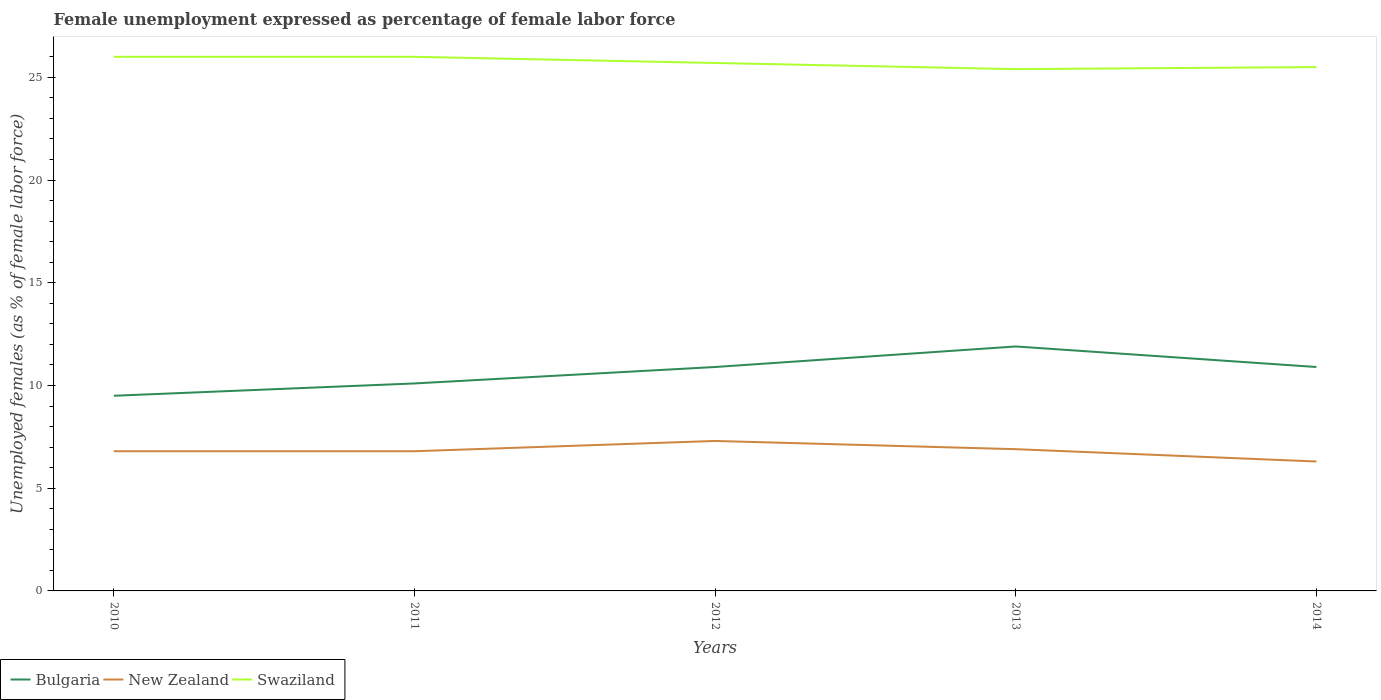How many different coloured lines are there?
Ensure brevity in your answer.  3. Across all years, what is the maximum unemployment in females in in Bulgaria?
Your answer should be compact. 9.5. What is the total unemployment in females in in Swaziland in the graph?
Provide a short and direct response. -0.1. What is the difference between the highest and the second highest unemployment in females in in New Zealand?
Ensure brevity in your answer.  1. What is the difference between the highest and the lowest unemployment in females in in New Zealand?
Your answer should be very brief. 2. How many lines are there?
Give a very brief answer. 3. What is the difference between two consecutive major ticks on the Y-axis?
Your response must be concise. 5. Are the values on the major ticks of Y-axis written in scientific E-notation?
Your answer should be compact. No. Does the graph contain any zero values?
Make the answer very short. No. Does the graph contain grids?
Ensure brevity in your answer.  No. How many legend labels are there?
Provide a succinct answer. 3. How are the legend labels stacked?
Your answer should be very brief. Horizontal. What is the title of the graph?
Ensure brevity in your answer.  Female unemployment expressed as percentage of female labor force. Does "Upper middle income" appear as one of the legend labels in the graph?
Offer a terse response. No. What is the label or title of the Y-axis?
Keep it short and to the point. Unemployed females (as % of female labor force). What is the Unemployed females (as % of female labor force) of New Zealand in 2010?
Provide a short and direct response. 6.8. What is the Unemployed females (as % of female labor force) in Bulgaria in 2011?
Your answer should be very brief. 10.1. What is the Unemployed females (as % of female labor force) of New Zealand in 2011?
Your answer should be compact. 6.8. What is the Unemployed females (as % of female labor force) of Swaziland in 2011?
Provide a succinct answer. 26. What is the Unemployed females (as % of female labor force) in Bulgaria in 2012?
Your response must be concise. 10.9. What is the Unemployed females (as % of female labor force) of New Zealand in 2012?
Your answer should be compact. 7.3. What is the Unemployed females (as % of female labor force) of Swaziland in 2012?
Offer a very short reply. 25.7. What is the Unemployed females (as % of female labor force) in Bulgaria in 2013?
Give a very brief answer. 11.9. What is the Unemployed females (as % of female labor force) of New Zealand in 2013?
Your answer should be compact. 6.9. What is the Unemployed females (as % of female labor force) in Swaziland in 2013?
Your response must be concise. 25.4. What is the Unemployed females (as % of female labor force) of Bulgaria in 2014?
Your answer should be compact. 10.9. What is the Unemployed females (as % of female labor force) in New Zealand in 2014?
Make the answer very short. 6.3. What is the Unemployed females (as % of female labor force) of Swaziland in 2014?
Keep it short and to the point. 25.5. Across all years, what is the maximum Unemployed females (as % of female labor force) of Bulgaria?
Provide a short and direct response. 11.9. Across all years, what is the maximum Unemployed females (as % of female labor force) of New Zealand?
Make the answer very short. 7.3. Across all years, what is the minimum Unemployed females (as % of female labor force) in New Zealand?
Offer a terse response. 6.3. Across all years, what is the minimum Unemployed females (as % of female labor force) of Swaziland?
Your answer should be very brief. 25.4. What is the total Unemployed females (as % of female labor force) of Bulgaria in the graph?
Ensure brevity in your answer.  53.3. What is the total Unemployed females (as % of female labor force) of New Zealand in the graph?
Give a very brief answer. 34.1. What is the total Unemployed females (as % of female labor force) of Swaziland in the graph?
Provide a short and direct response. 128.6. What is the difference between the Unemployed females (as % of female labor force) in Bulgaria in 2010 and that in 2011?
Your answer should be compact. -0.6. What is the difference between the Unemployed females (as % of female labor force) of Swaziland in 2010 and that in 2012?
Make the answer very short. 0.3. What is the difference between the Unemployed females (as % of female labor force) in New Zealand in 2010 and that in 2013?
Offer a terse response. -0.1. What is the difference between the Unemployed females (as % of female labor force) in Swaziland in 2010 and that in 2013?
Ensure brevity in your answer.  0.6. What is the difference between the Unemployed females (as % of female labor force) of Bulgaria in 2010 and that in 2014?
Offer a terse response. -1.4. What is the difference between the Unemployed females (as % of female labor force) of New Zealand in 2011 and that in 2012?
Make the answer very short. -0.5. What is the difference between the Unemployed females (as % of female labor force) in Swaziland in 2011 and that in 2012?
Provide a short and direct response. 0.3. What is the difference between the Unemployed females (as % of female labor force) of Bulgaria in 2011 and that in 2013?
Offer a very short reply. -1.8. What is the difference between the Unemployed females (as % of female labor force) in Bulgaria in 2011 and that in 2014?
Offer a very short reply. -0.8. What is the difference between the Unemployed females (as % of female labor force) in New Zealand in 2011 and that in 2014?
Provide a short and direct response. 0.5. What is the difference between the Unemployed females (as % of female labor force) of New Zealand in 2012 and that in 2013?
Give a very brief answer. 0.4. What is the difference between the Unemployed females (as % of female labor force) in Swaziland in 2012 and that in 2013?
Offer a terse response. 0.3. What is the difference between the Unemployed females (as % of female labor force) in New Zealand in 2012 and that in 2014?
Offer a very short reply. 1. What is the difference between the Unemployed females (as % of female labor force) of Bulgaria in 2013 and that in 2014?
Keep it short and to the point. 1. What is the difference between the Unemployed females (as % of female labor force) in New Zealand in 2013 and that in 2014?
Your answer should be very brief. 0.6. What is the difference between the Unemployed females (as % of female labor force) in Swaziland in 2013 and that in 2014?
Offer a very short reply. -0.1. What is the difference between the Unemployed females (as % of female labor force) in Bulgaria in 2010 and the Unemployed females (as % of female labor force) in Swaziland in 2011?
Your response must be concise. -16.5. What is the difference between the Unemployed females (as % of female labor force) of New Zealand in 2010 and the Unemployed females (as % of female labor force) of Swaziland in 2011?
Provide a short and direct response. -19.2. What is the difference between the Unemployed females (as % of female labor force) of Bulgaria in 2010 and the Unemployed females (as % of female labor force) of Swaziland in 2012?
Your answer should be compact. -16.2. What is the difference between the Unemployed females (as % of female labor force) in New Zealand in 2010 and the Unemployed females (as % of female labor force) in Swaziland in 2012?
Offer a terse response. -18.9. What is the difference between the Unemployed females (as % of female labor force) in Bulgaria in 2010 and the Unemployed females (as % of female labor force) in New Zealand in 2013?
Keep it short and to the point. 2.6. What is the difference between the Unemployed females (as % of female labor force) of Bulgaria in 2010 and the Unemployed females (as % of female labor force) of Swaziland in 2013?
Your answer should be compact. -15.9. What is the difference between the Unemployed females (as % of female labor force) in New Zealand in 2010 and the Unemployed females (as % of female labor force) in Swaziland in 2013?
Give a very brief answer. -18.6. What is the difference between the Unemployed females (as % of female labor force) of Bulgaria in 2010 and the Unemployed females (as % of female labor force) of New Zealand in 2014?
Provide a short and direct response. 3.2. What is the difference between the Unemployed females (as % of female labor force) of Bulgaria in 2010 and the Unemployed females (as % of female labor force) of Swaziland in 2014?
Give a very brief answer. -16. What is the difference between the Unemployed females (as % of female labor force) of New Zealand in 2010 and the Unemployed females (as % of female labor force) of Swaziland in 2014?
Ensure brevity in your answer.  -18.7. What is the difference between the Unemployed females (as % of female labor force) in Bulgaria in 2011 and the Unemployed females (as % of female labor force) in New Zealand in 2012?
Ensure brevity in your answer.  2.8. What is the difference between the Unemployed females (as % of female labor force) in Bulgaria in 2011 and the Unemployed females (as % of female labor force) in Swaziland in 2012?
Provide a succinct answer. -15.6. What is the difference between the Unemployed females (as % of female labor force) in New Zealand in 2011 and the Unemployed females (as % of female labor force) in Swaziland in 2012?
Offer a very short reply. -18.9. What is the difference between the Unemployed females (as % of female labor force) in Bulgaria in 2011 and the Unemployed females (as % of female labor force) in New Zealand in 2013?
Ensure brevity in your answer.  3.2. What is the difference between the Unemployed females (as % of female labor force) in Bulgaria in 2011 and the Unemployed females (as % of female labor force) in Swaziland in 2013?
Make the answer very short. -15.3. What is the difference between the Unemployed females (as % of female labor force) of New Zealand in 2011 and the Unemployed females (as % of female labor force) of Swaziland in 2013?
Give a very brief answer. -18.6. What is the difference between the Unemployed females (as % of female labor force) of Bulgaria in 2011 and the Unemployed females (as % of female labor force) of New Zealand in 2014?
Your response must be concise. 3.8. What is the difference between the Unemployed females (as % of female labor force) of Bulgaria in 2011 and the Unemployed females (as % of female labor force) of Swaziland in 2014?
Provide a short and direct response. -15.4. What is the difference between the Unemployed females (as % of female labor force) of New Zealand in 2011 and the Unemployed females (as % of female labor force) of Swaziland in 2014?
Make the answer very short. -18.7. What is the difference between the Unemployed females (as % of female labor force) of New Zealand in 2012 and the Unemployed females (as % of female labor force) of Swaziland in 2013?
Make the answer very short. -18.1. What is the difference between the Unemployed females (as % of female labor force) in Bulgaria in 2012 and the Unemployed females (as % of female labor force) in Swaziland in 2014?
Your response must be concise. -14.6. What is the difference between the Unemployed females (as % of female labor force) in New Zealand in 2012 and the Unemployed females (as % of female labor force) in Swaziland in 2014?
Ensure brevity in your answer.  -18.2. What is the difference between the Unemployed females (as % of female labor force) of Bulgaria in 2013 and the Unemployed females (as % of female labor force) of Swaziland in 2014?
Ensure brevity in your answer.  -13.6. What is the difference between the Unemployed females (as % of female labor force) in New Zealand in 2013 and the Unemployed females (as % of female labor force) in Swaziland in 2014?
Provide a succinct answer. -18.6. What is the average Unemployed females (as % of female labor force) in Bulgaria per year?
Provide a short and direct response. 10.66. What is the average Unemployed females (as % of female labor force) in New Zealand per year?
Ensure brevity in your answer.  6.82. What is the average Unemployed females (as % of female labor force) in Swaziland per year?
Provide a short and direct response. 25.72. In the year 2010, what is the difference between the Unemployed females (as % of female labor force) of Bulgaria and Unemployed females (as % of female labor force) of Swaziland?
Keep it short and to the point. -16.5. In the year 2010, what is the difference between the Unemployed females (as % of female labor force) in New Zealand and Unemployed females (as % of female labor force) in Swaziland?
Provide a short and direct response. -19.2. In the year 2011, what is the difference between the Unemployed females (as % of female labor force) of Bulgaria and Unemployed females (as % of female labor force) of Swaziland?
Offer a very short reply. -15.9. In the year 2011, what is the difference between the Unemployed females (as % of female labor force) of New Zealand and Unemployed females (as % of female labor force) of Swaziland?
Provide a succinct answer. -19.2. In the year 2012, what is the difference between the Unemployed females (as % of female labor force) of Bulgaria and Unemployed females (as % of female labor force) of Swaziland?
Give a very brief answer. -14.8. In the year 2012, what is the difference between the Unemployed females (as % of female labor force) in New Zealand and Unemployed females (as % of female labor force) in Swaziland?
Offer a very short reply. -18.4. In the year 2013, what is the difference between the Unemployed females (as % of female labor force) in Bulgaria and Unemployed females (as % of female labor force) in New Zealand?
Your answer should be very brief. 5. In the year 2013, what is the difference between the Unemployed females (as % of female labor force) in Bulgaria and Unemployed females (as % of female labor force) in Swaziland?
Offer a very short reply. -13.5. In the year 2013, what is the difference between the Unemployed females (as % of female labor force) of New Zealand and Unemployed females (as % of female labor force) of Swaziland?
Give a very brief answer. -18.5. In the year 2014, what is the difference between the Unemployed females (as % of female labor force) of Bulgaria and Unemployed females (as % of female labor force) of Swaziland?
Your answer should be very brief. -14.6. In the year 2014, what is the difference between the Unemployed females (as % of female labor force) of New Zealand and Unemployed females (as % of female labor force) of Swaziland?
Keep it short and to the point. -19.2. What is the ratio of the Unemployed females (as % of female labor force) of Bulgaria in 2010 to that in 2011?
Your answer should be very brief. 0.94. What is the ratio of the Unemployed females (as % of female labor force) of Bulgaria in 2010 to that in 2012?
Offer a terse response. 0.87. What is the ratio of the Unemployed females (as % of female labor force) in New Zealand in 2010 to that in 2012?
Your answer should be very brief. 0.93. What is the ratio of the Unemployed females (as % of female labor force) of Swaziland in 2010 to that in 2012?
Provide a short and direct response. 1.01. What is the ratio of the Unemployed females (as % of female labor force) of Bulgaria in 2010 to that in 2013?
Give a very brief answer. 0.8. What is the ratio of the Unemployed females (as % of female labor force) of New Zealand in 2010 to that in 2013?
Make the answer very short. 0.99. What is the ratio of the Unemployed females (as % of female labor force) in Swaziland in 2010 to that in 2013?
Your answer should be compact. 1.02. What is the ratio of the Unemployed females (as % of female labor force) of Bulgaria in 2010 to that in 2014?
Your answer should be compact. 0.87. What is the ratio of the Unemployed females (as % of female labor force) of New Zealand in 2010 to that in 2014?
Ensure brevity in your answer.  1.08. What is the ratio of the Unemployed females (as % of female labor force) in Swaziland in 2010 to that in 2014?
Give a very brief answer. 1.02. What is the ratio of the Unemployed females (as % of female labor force) of Bulgaria in 2011 to that in 2012?
Provide a short and direct response. 0.93. What is the ratio of the Unemployed females (as % of female labor force) of New Zealand in 2011 to that in 2012?
Give a very brief answer. 0.93. What is the ratio of the Unemployed females (as % of female labor force) of Swaziland in 2011 to that in 2012?
Offer a very short reply. 1.01. What is the ratio of the Unemployed females (as % of female labor force) of Bulgaria in 2011 to that in 2013?
Ensure brevity in your answer.  0.85. What is the ratio of the Unemployed females (as % of female labor force) in New Zealand in 2011 to that in 2013?
Give a very brief answer. 0.99. What is the ratio of the Unemployed females (as % of female labor force) of Swaziland in 2011 to that in 2013?
Your response must be concise. 1.02. What is the ratio of the Unemployed females (as % of female labor force) of Bulgaria in 2011 to that in 2014?
Your answer should be compact. 0.93. What is the ratio of the Unemployed females (as % of female labor force) in New Zealand in 2011 to that in 2014?
Keep it short and to the point. 1.08. What is the ratio of the Unemployed females (as % of female labor force) of Swaziland in 2011 to that in 2014?
Offer a terse response. 1.02. What is the ratio of the Unemployed females (as % of female labor force) of Bulgaria in 2012 to that in 2013?
Your response must be concise. 0.92. What is the ratio of the Unemployed females (as % of female labor force) of New Zealand in 2012 to that in 2013?
Provide a succinct answer. 1.06. What is the ratio of the Unemployed females (as % of female labor force) in Swaziland in 2012 to that in 2013?
Provide a short and direct response. 1.01. What is the ratio of the Unemployed females (as % of female labor force) of New Zealand in 2012 to that in 2014?
Provide a succinct answer. 1.16. What is the ratio of the Unemployed females (as % of female labor force) of Swaziland in 2012 to that in 2014?
Offer a very short reply. 1.01. What is the ratio of the Unemployed females (as % of female labor force) in Bulgaria in 2013 to that in 2014?
Offer a very short reply. 1.09. What is the ratio of the Unemployed females (as % of female labor force) of New Zealand in 2013 to that in 2014?
Offer a very short reply. 1.1. What is the difference between the highest and the second highest Unemployed females (as % of female labor force) of Bulgaria?
Offer a very short reply. 1. What is the difference between the highest and the lowest Unemployed females (as % of female labor force) of Bulgaria?
Provide a short and direct response. 2.4. What is the difference between the highest and the lowest Unemployed females (as % of female labor force) in New Zealand?
Make the answer very short. 1. What is the difference between the highest and the lowest Unemployed females (as % of female labor force) in Swaziland?
Make the answer very short. 0.6. 